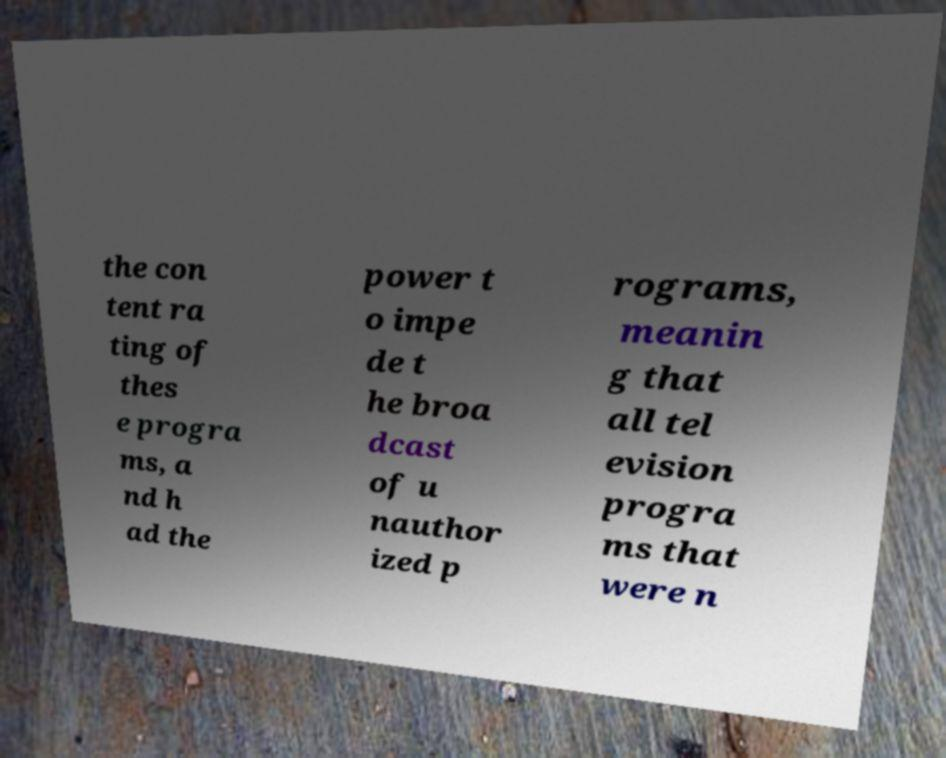Can you read and provide the text displayed in the image?This photo seems to have some interesting text. Can you extract and type it out for me? the con tent ra ting of thes e progra ms, a nd h ad the power t o impe de t he broa dcast of u nauthor ized p rograms, meanin g that all tel evision progra ms that were n 